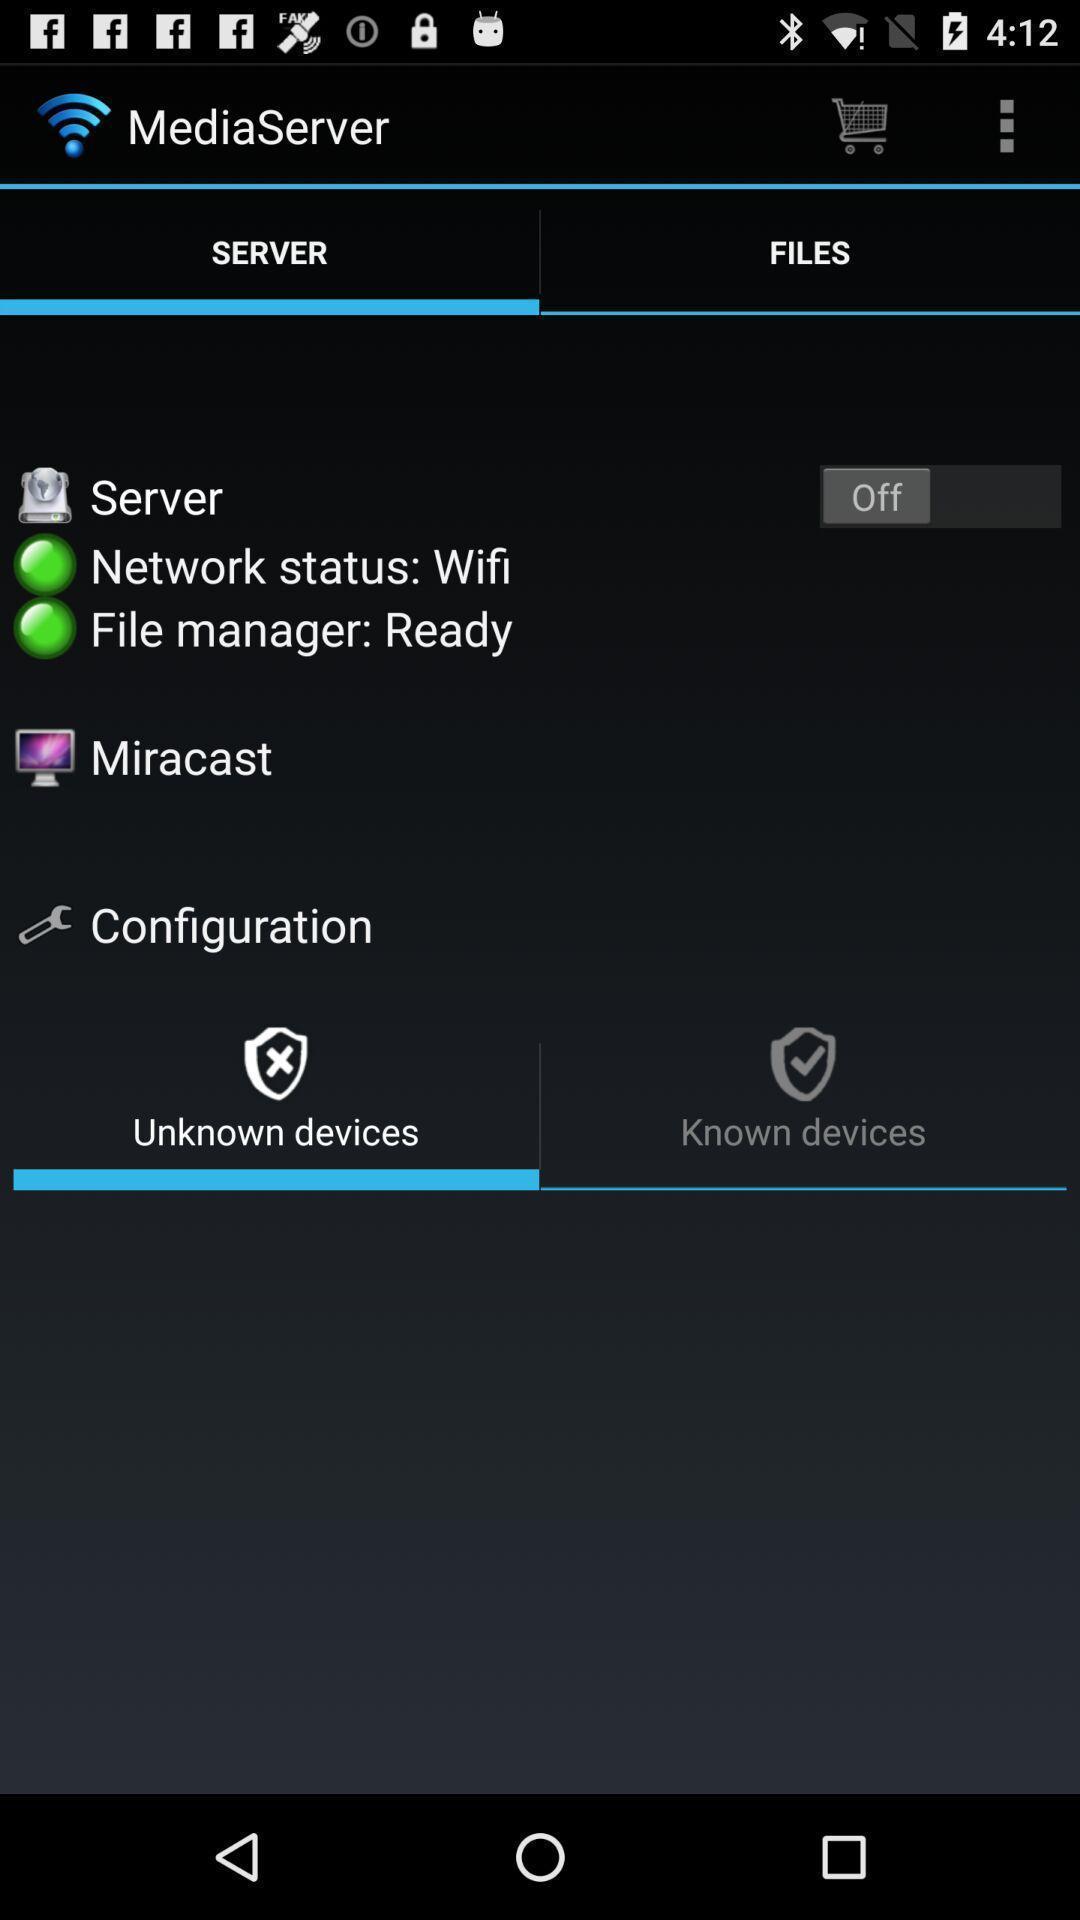Summarize the information in this screenshot. Various options. 